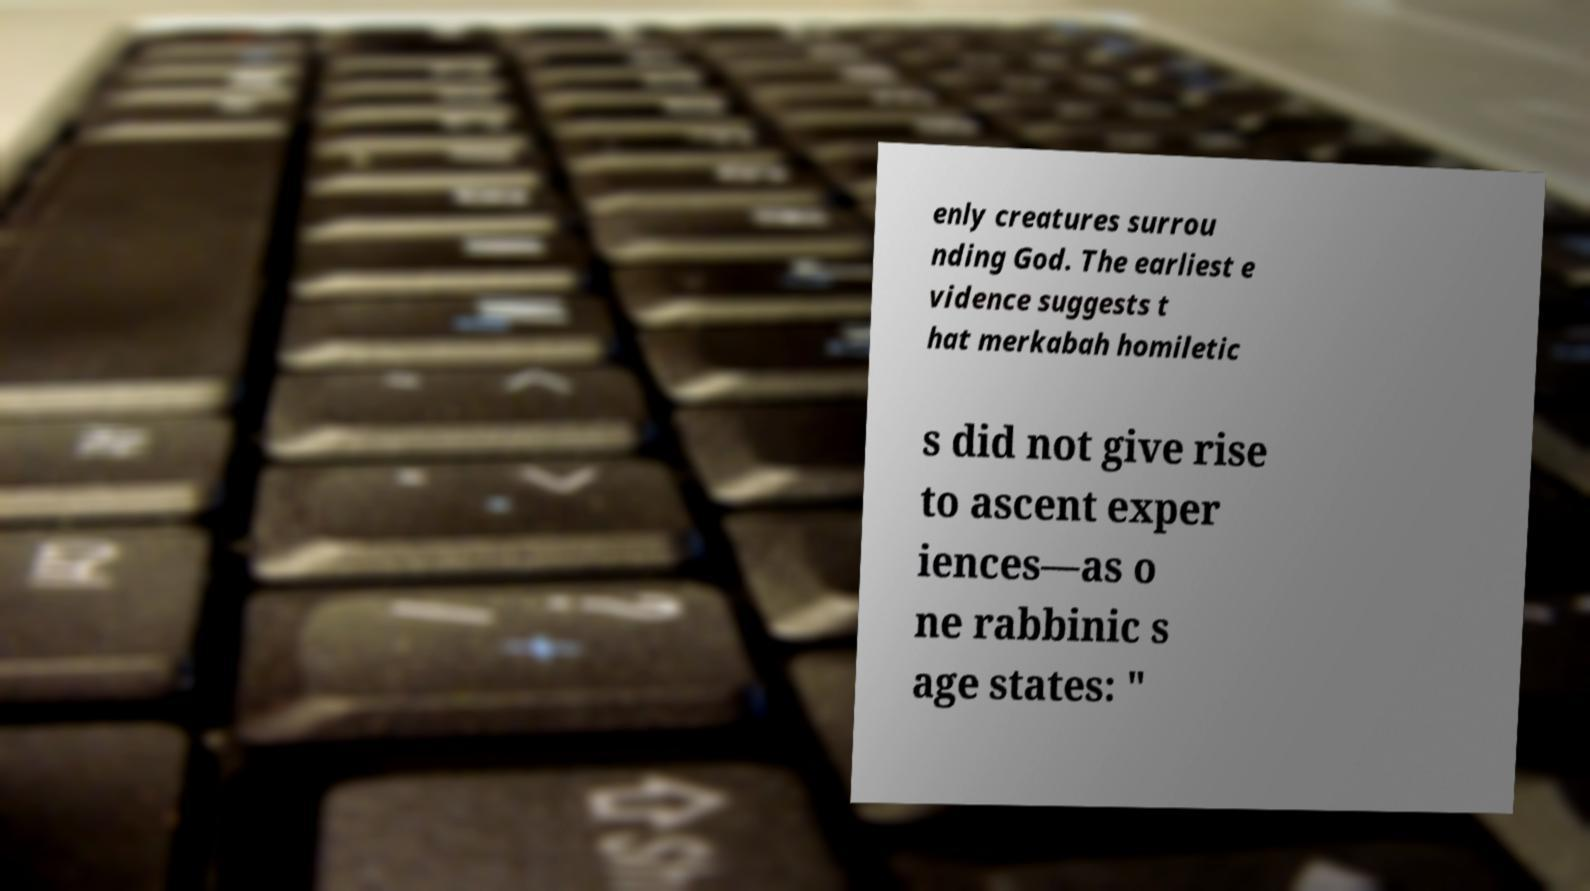Can you accurately transcribe the text from the provided image for me? enly creatures surrou nding God. The earliest e vidence suggests t hat merkabah homiletic s did not give rise to ascent exper iences—as o ne rabbinic s age states: " 